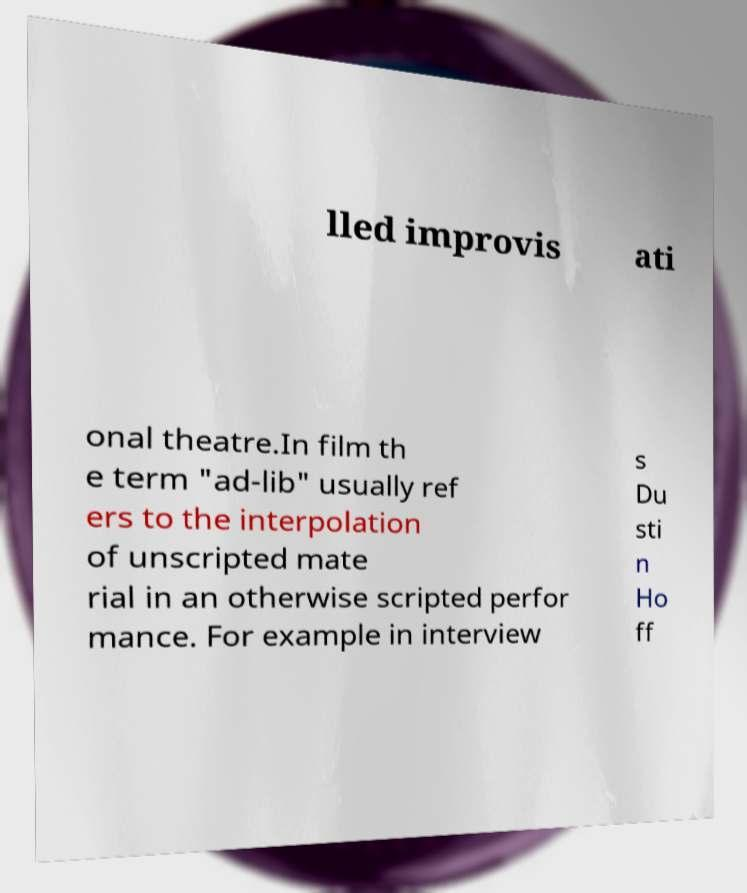Can you read and provide the text displayed in the image?This photo seems to have some interesting text. Can you extract and type it out for me? lled improvis ati onal theatre.In film th e term "ad-lib" usually ref ers to the interpolation of unscripted mate rial in an otherwise scripted perfor mance. For example in interview s Du sti n Ho ff 